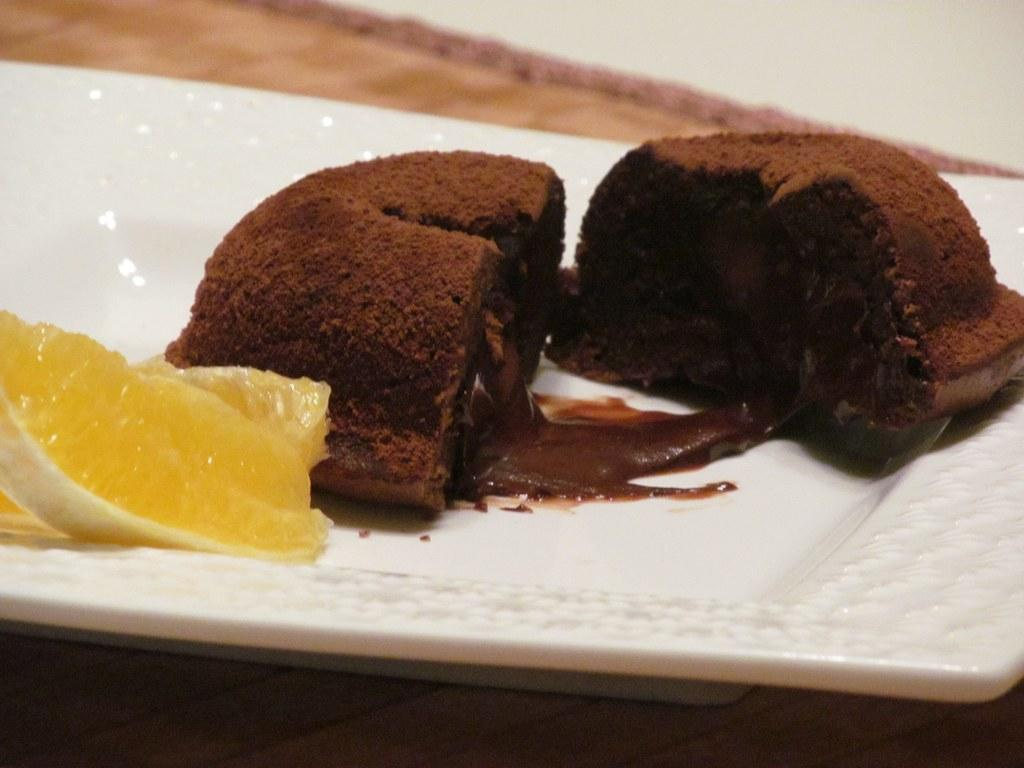What type of cake is shown in the image? There is a chocolate cake in the image. Are there any additional toppings or decorations on the cake? Yes, there is a piece of orange on the cake. What is the cake placed on? The cake is on a plate. How does the zipper on the cake work? There is no zipper present on the cake; it is a chocolate cake with a piece of orange on top. 